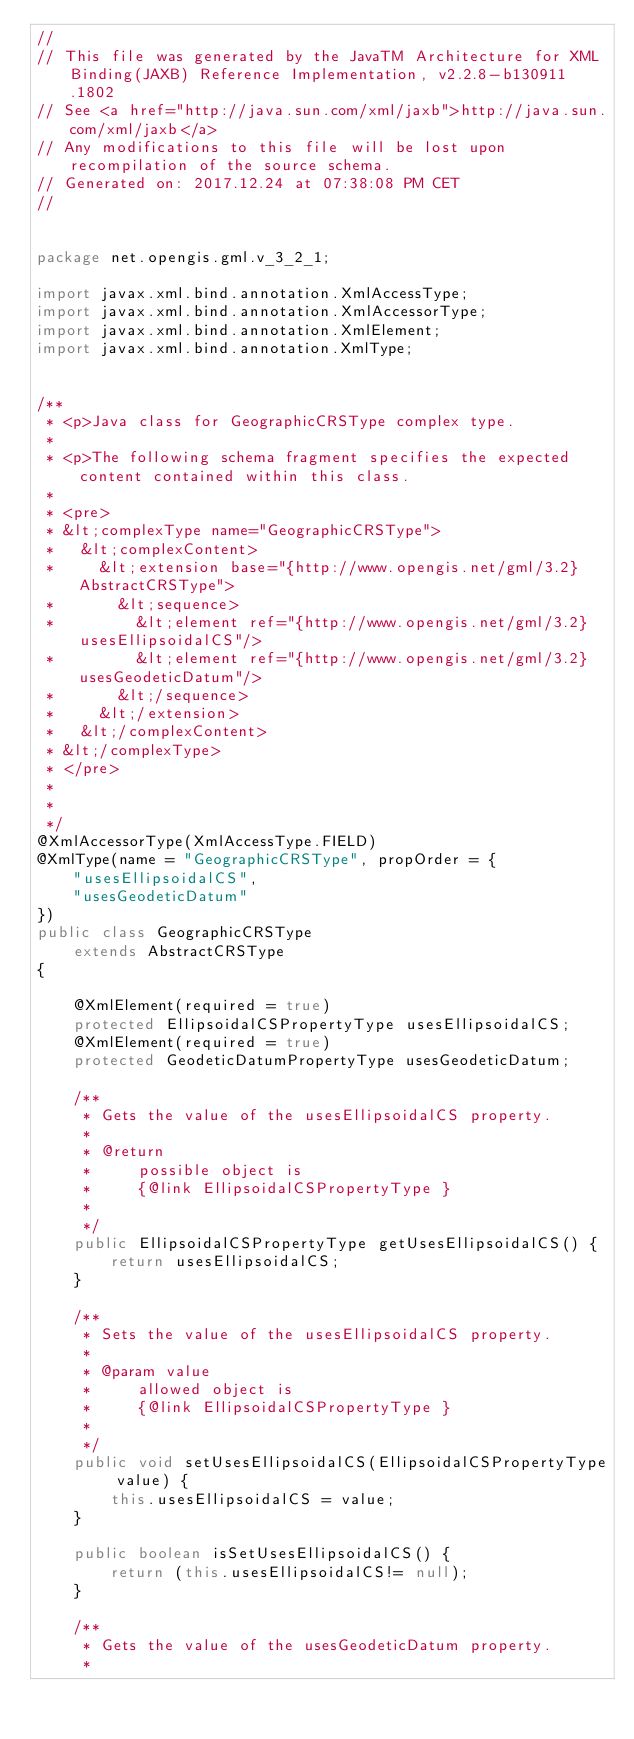Convert code to text. <code><loc_0><loc_0><loc_500><loc_500><_Java_>//
// This file was generated by the JavaTM Architecture for XML Binding(JAXB) Reference Implementation, v2.2.8-b130911.1802 
// See <a href="http://java.sun.com/xml/jaxb">http://java.sun.com/xml/jaxb</a> 
// Any modifications to this file will be lost upon recompilation of the source schema. 
// Generated on: 2017.12.24 at 07:38:08 PM CET 
//


package net.opengis.gml.v_3_2_1;

import javax.xml.bind.annotation.XmlAccessType;
import javax.xml.bind.annotation.XmlAccessorType;
import javax.xml.bind.annotation.XmlElement;
import javax.xml.bind.annotation.XmlType;


/**
 * <p>Java class for GeographicCRSType complex type.
 * 
 * <p>The following schema fragment specifies the expected content contained within this class.
 * 
 * <pre>
 * &lt;complexType name="GeographicCRSType">
 *   &lt;complexContent>
 *     &lt;extension base="{http://www.opengis.net/gml/3.2}AbstractCRSType">
 *       &lt;sequence>
 *         &lt;element ref="{http://www.opengis.net/gml/3.2}usesEllipsoidalCS"/>
 *         &lt;element ref="{http://www.opengis.net/gml/3.2}usesGeodeticDatum"/>
 *       &lt;/sequence>
 *     &lt;/extension>
 *   &lt;/complexContent>
 * &lt;/complexType>
 * </pre>
 * 
 * 
 */
@XmlAccessorType(XmlAccessType.FIELD)
@XmlType(name = "GeographicCRSType", propOrder = {
    "usesEllipsoidalCS",
    "usesGeodeticDatum"
})
public class GeographicCRSType
    extends AbstractCRSType
{

    @XmlElement(required = true)
    protected EllipsoidalCSPropertyType usesEllipsoidalCS;
    @XmlElement(required = true)
    protected GeodeticDatumPropertyType usesGeodeticDatum;

    /**
     * Gets the value of the usesEllipsoidalCS property.
     * 
     * @return
     *     possible object is
     *     {@link EllipsoidalCSPropertyType }
     *     
     */
    public EllipsoidalCSPropertyType getUsesEllipsoidalCS() {
        return usesEllipsoidalCS;
    }

    /**
     * Sets the value of the usesEllipsoidalCS property.
     * 
     * @param value
     *     allowed object is
     *     {@link EllipsoidalCSPropertyType }
     *     
     */
    public void setUsesEllipsoidalCS(EllipsoidalCSPropertyType value) {
        this.usesEllipsoidalCS = value;
    }

    public boolean isSetUsesEllipsoidalCS() {
        return (this.usesEllipsoidalCS!= null);
    }

    /**
     * Gets the value of the usesGeodeticDatum property.
     * </code> 